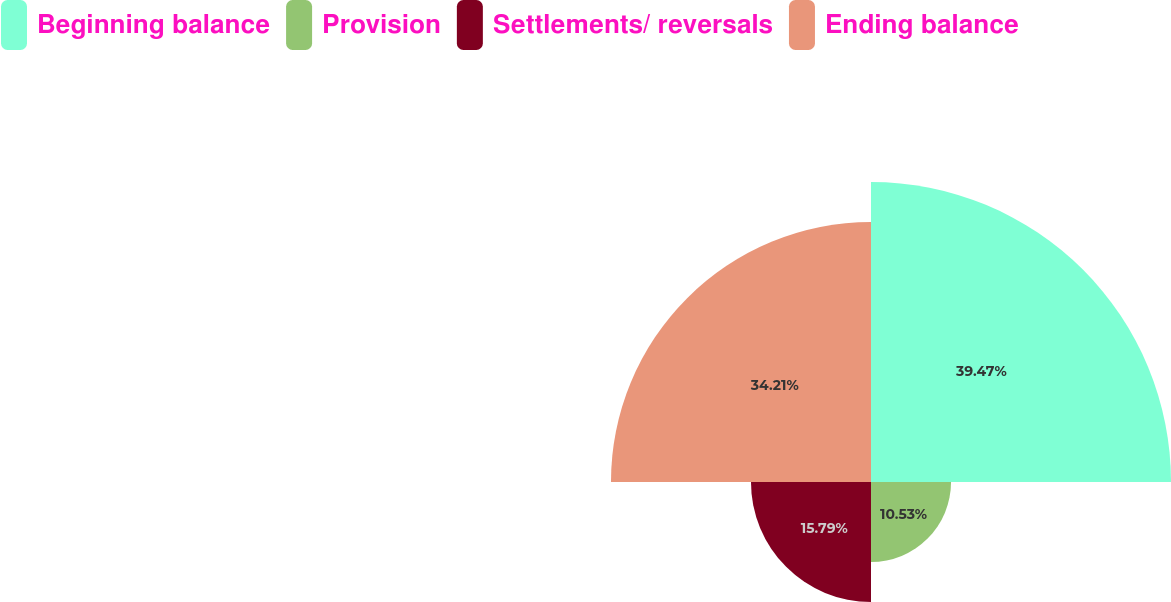<chart> <loc_0><loc_0><loc_500><loc_500><pie_chart><fcel>Beginning balance<fcel>Provision<fcel>Settlements/ reversals<fcel>Ending balance<nl><fcel>39.47%<fcel>10.53%<fcel>15.79%<fcel>34.21%<nl></chart> 